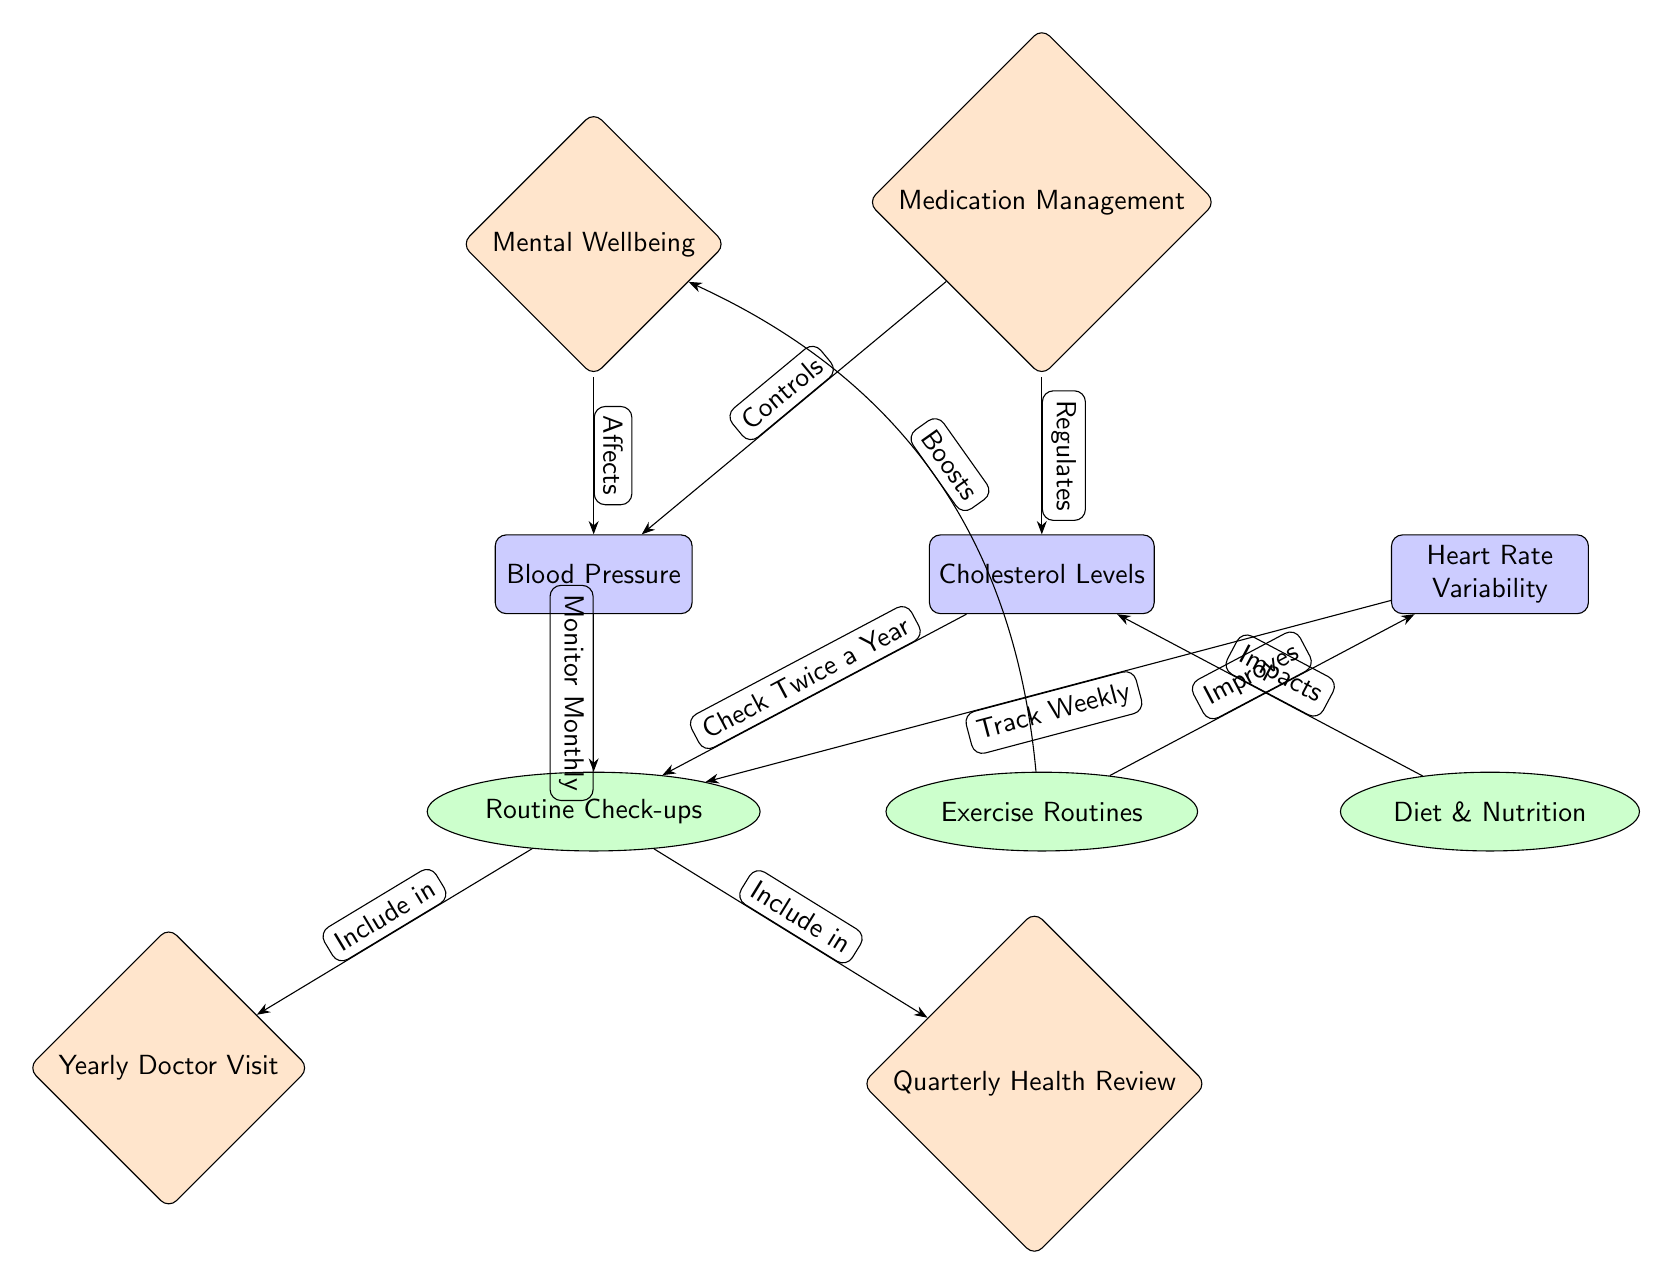What are the main cardiovascular health metrics listed in the diagram? The diagram contains three main health metrics, which are Blood Pressure, Cholesterol Levels, and Heart Rate Variability. These can be identified as the primary nodes at the top of the diagram.
Answer: Blood Pressure, Cholesterol Levels, Heart Rate Variability How often should blood pressure be monitored? The diagram indicates that blood pressure should be monitored monthly, as stated in the edge connecting Blood Pressure to Routine Check-ups.
Answer: Monthly What impacts cholesterol levels according to the diagram? The diagram shows a connection indicating that Diet & Nutrition impacts Cholesterol Levels. This means that the secondary node Diet & Nutrition is directly connected to the main metric Cholesterol Levels.
Answer: Diet & Nutrition What are the two specific types of routine check-ups mentioned? The diagram lists two routine check-ups, which are Yearly Doctor Visit and Quarterly Health Review. These are located below the Routine Check-ups node and can be identified as tertiary nodes.
Answer: Yearly Doctor Visit, Quarterly Health Review How does exercise affect heart rate variability? The edge from Exercise Routines to Heart Rate Variability indicates that exercise improves heart rate variability. Thus, the relationship shows a positive effect where exercise routines are connected to enhancing heart rate variability.
Answer: Improves What relationship does mental wellbeing have with blood pressure? The diagram illustrates that mental wellbeing affects blood pressure. This is shown by the edge connecting the Mental Wellbeing node to the Blood Pressure node.
Answer: Affects Which component regulates cholesterol levels? The diagram states that Medication Management regulates cholesterol levels, as evidenced by the direct edge pointing from Medication Management to Cholesterol Levels.
Answer: Medication Management How frequently should heart rate variability be tracked? According to the diagram, heart rate variability should be tracked weekly, which is provided by the edge linking Heart Rate Variability to Routine Check-ups.
Answer: Weekly What is an example of how exercise routines and mental wellbeing are connected? The diagram shows that exercise routines boost mental wellbeing, as indicated by the edge that bends around to link these two nodes. This demonstrates how engaging in physical activity can improve mental health.
Answer: Boosts 